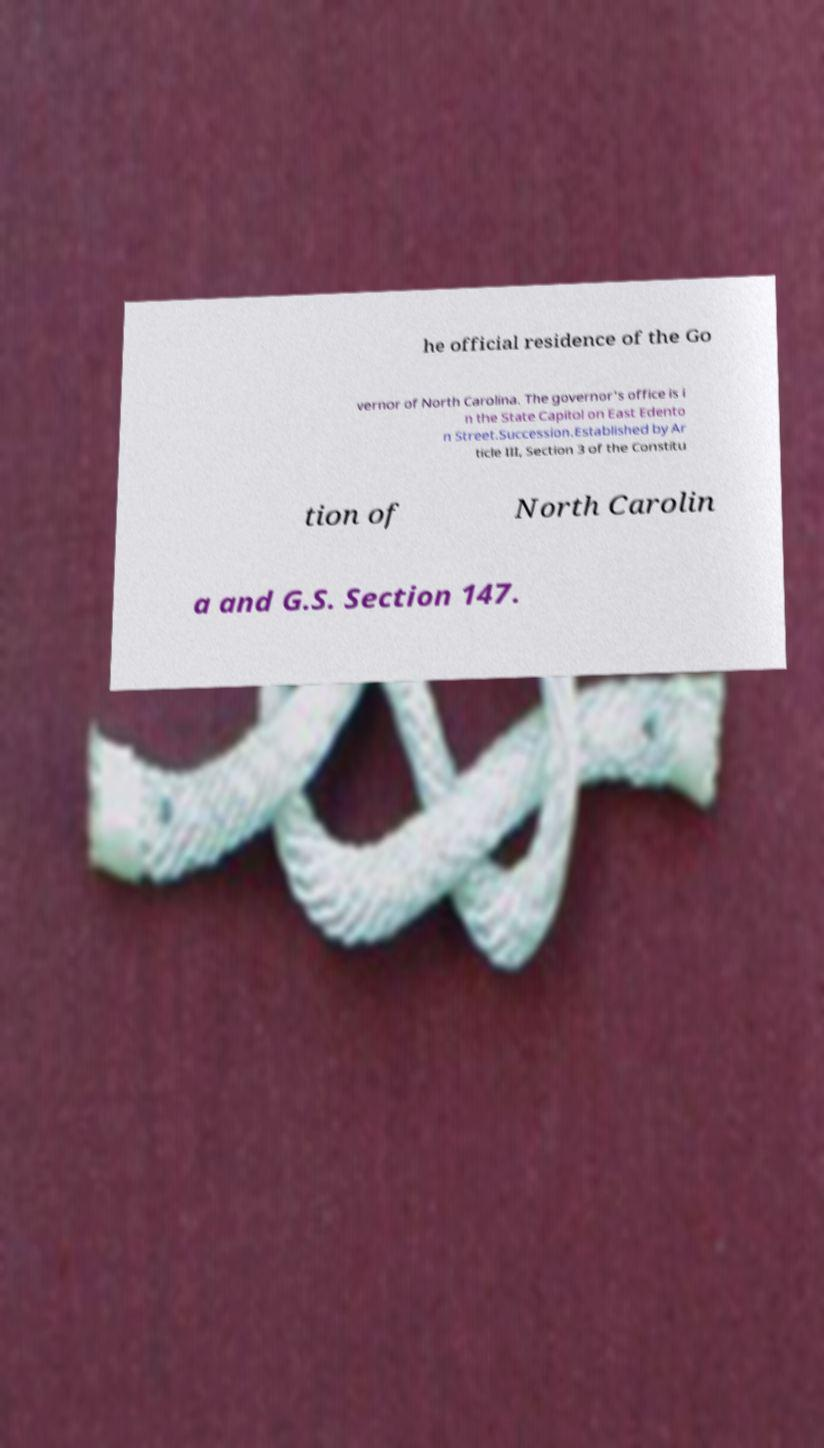Could you assist in decoding the text presented in this image and type it out clearly? he official residence of the Go vernor of North Carolina. The governor's office is i n the State Capitol on East Edento n Street.Succession.Established by Ar ticle III, Section 3 of the Constitu tion of North Carolin a and G.S. Section 147. 